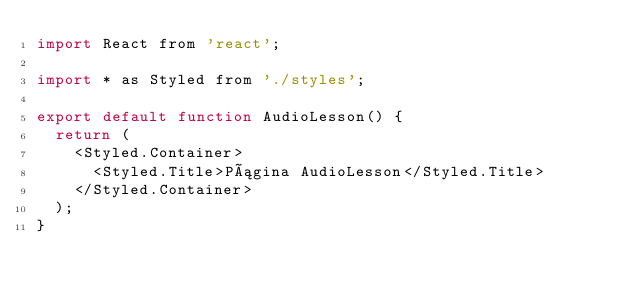Convert code to text. <code><loc_0><loc_0><loc_500><loc_500><_JavaScript_>import React from 'react';

import * as Styled from './styles';

export default function AudioLesson() {
  return (
    <Styled.Container>
      <Styled.Title>Página AudioLesson</Styled.Title>
    </Styled.Container>
  );
}
</code> 